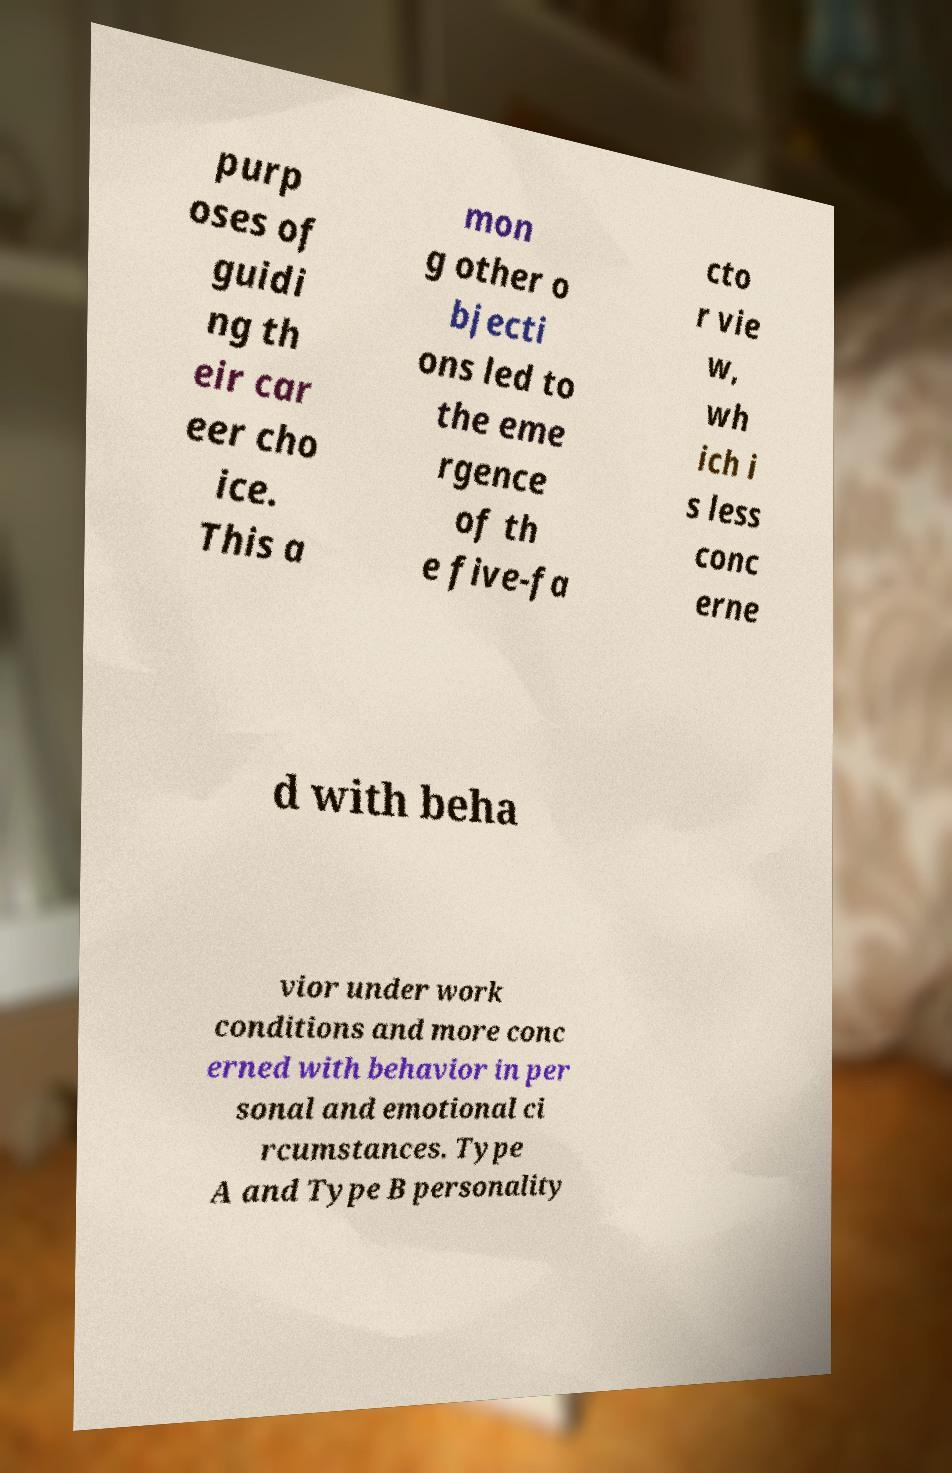Please read and relay the text visible in this image. What does it say? purp oses of guidi ng th eir car eer cho ice. This a mon g other o bjecti ons led to the eme rgence of th e five-fa cto r vie w, wh ich i s less conc erne d with beha vior under work conditions and more conc erned with behavior in per sonal and emotional ci rcumstances. Type A and Type B personality 